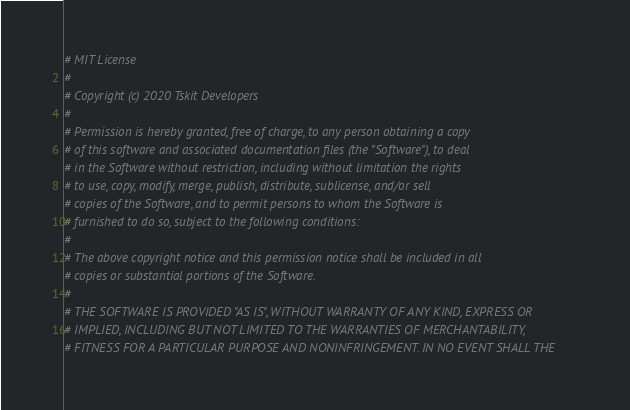Convert code to text. <code><loc_0><loc_0><loc_500><loc_500><_Python_># MIT License
#
# Copyright (c) 2020 Tskit Developers
#
# Permission is hereby granted, free of charge, to any person obtaining a copy
# of this software and associated documentation files (the "Software"), to deal
# in the Software without restriction, including without limitation the rights
# to use, copy, modify, merge, publish, distribute, sublicense, and/or sell
# copies of the Software, and to permit persons to whom the Software is
# furnished to do so, subject to the following conditions:
#
# The above copyright notice and this permission notice shall be included in all
# copies or substantial portions of the Software.
#
# THE SOFTWARE IS PROVIDED "AS IS", WITHOUT WARRANTY OF ANY KIND, EXPRESS OR
# IMPLIED, INCLUDING BUT NOT LIMITED TO THE WARRANTIES OF MERCHANTABILITY,
# FITNESS FOR A PARTICULAR PURPOSE AND NONINFRINGEMENT. IN NO EVENT SHALL THE</code> 